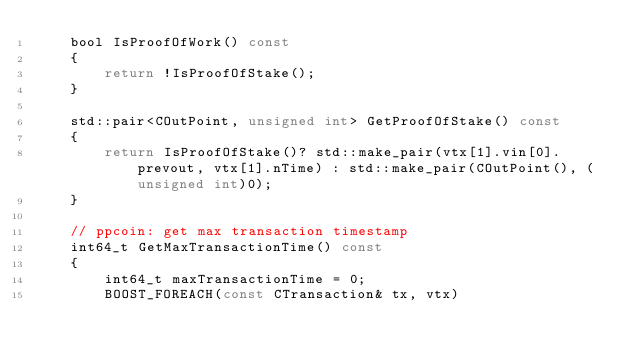Convert code to text. <code><loc_0><loc_0><loc_500><loc_500><_C_>    bool IsProofOfWork() const
    {
        return !IsProofOfStake();
    }

    std::pair<COutPoint, unsigned int> GetProofOfStake() const
    {
        return IsProofOfStake()? std::make_pair(vtx[1].vin[0].prevout, vtx[1].nTime) : std::make_pair(COutPoint(), (unsigned int)0);
    }

    // ppcoin: get max transaction timestamp
    int64_t GetMaxTransactionTime() const
    {
        int64_t maxTransactionTime = 0;
        BOOST_FOREACH(const CTransaction& tx, vtx)</code> 